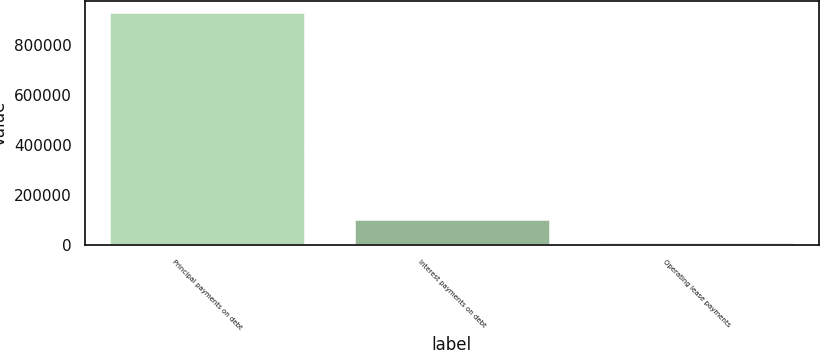Convert chart. <chart><loc_0><loc_0><loc_500><loc_500><bar_chart><fcel>Principal payments on debt<fcel>Interest payments on debt<fcel>Operating lease payments<nl><fcel>932540<fcel>106096<fcel>14269<nl></chart> 